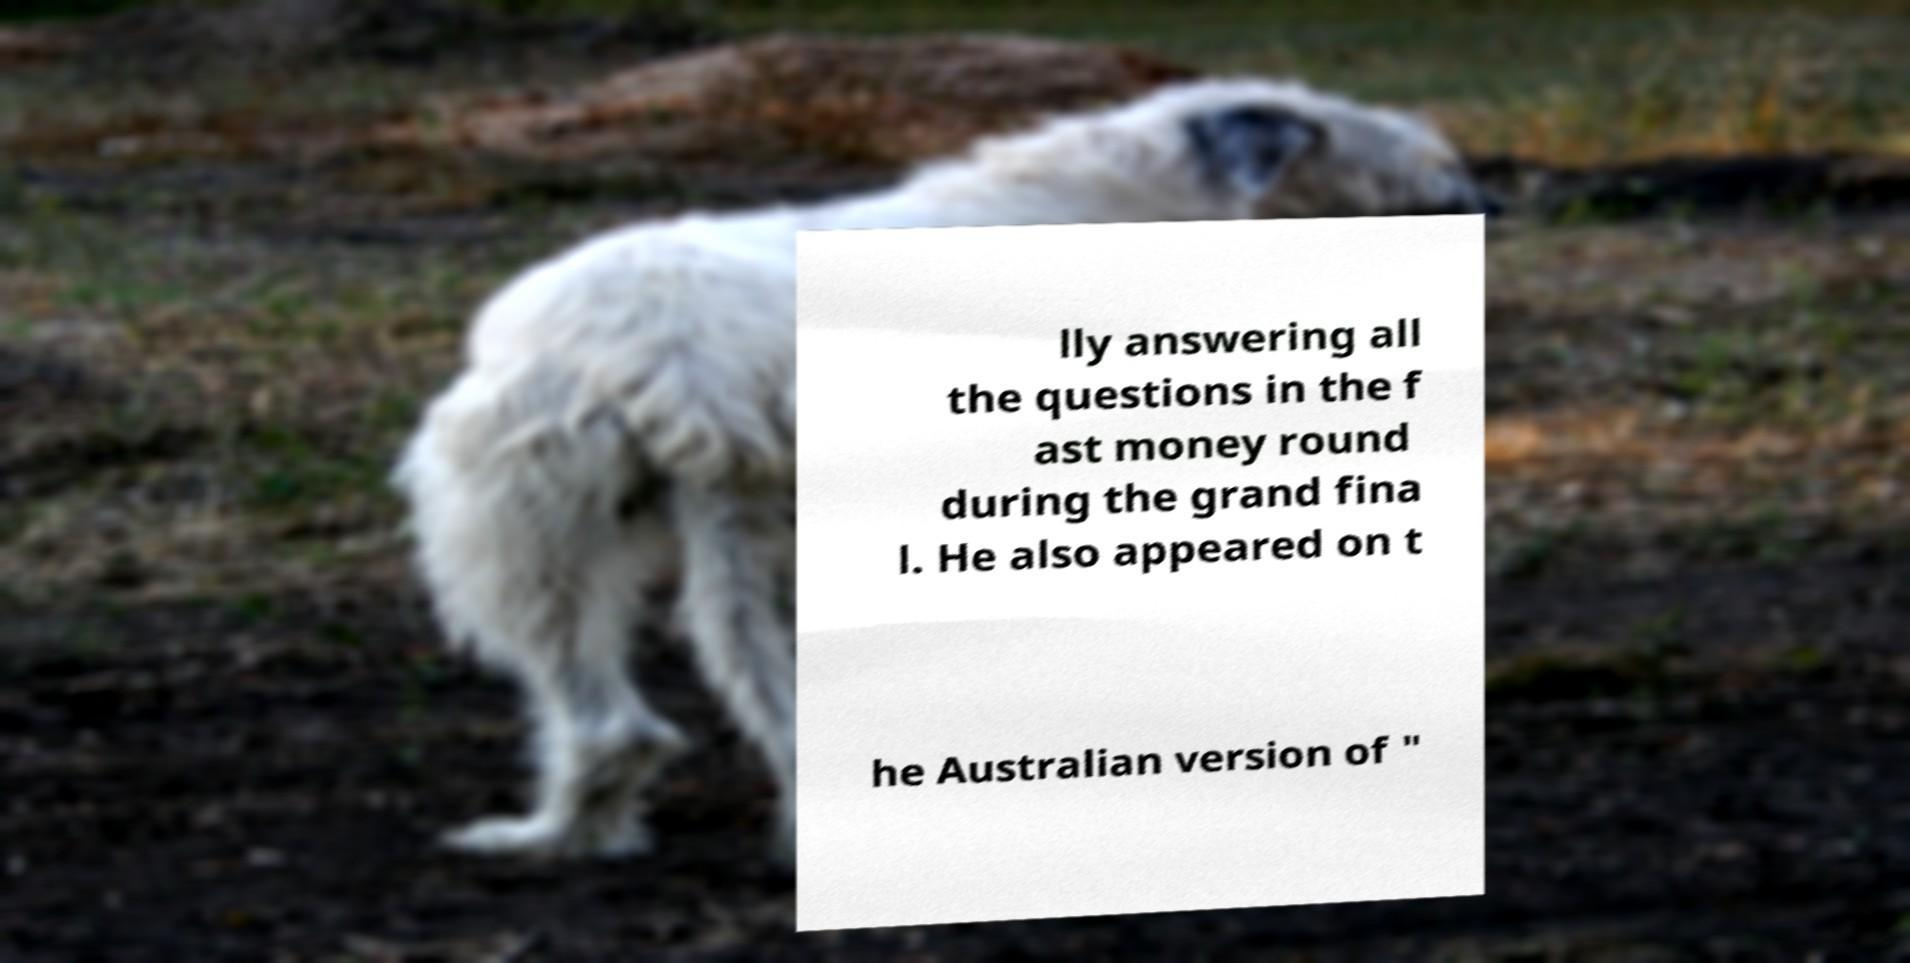Can you read and provide the text displayed in the image?This photo seems to have some interesting text. Can you extract and type it out for me? lly answering all the questions in the f ast money round during the grand fina l. He also appeared on t he Australian version of " 